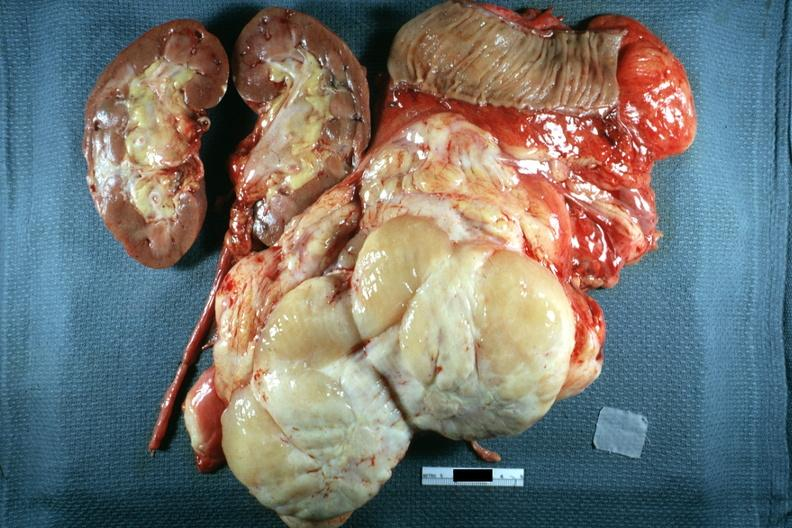what is present?
Answer the question using a single word or phrase. Peritoneum 